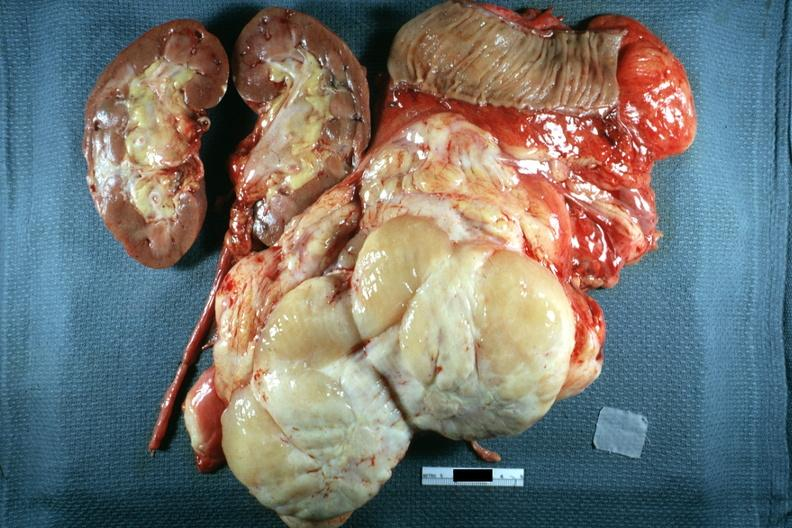what is present?
Answer the question using a single word or phrase. Peritoneum 